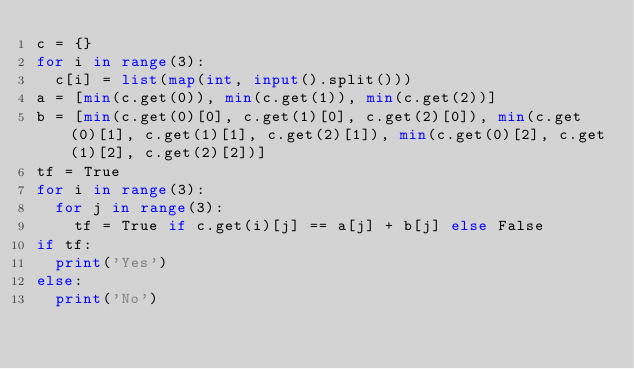<code> <loc_0><loc_0><loc_500><loc_500><_Python_>c = {}
for i in range(3):
  c[i] = list(map(int, input().split()))
a = [min(c.get(0)), min(c.get(1)), min(c.get(2))]
b = [min(c.get(0)[0], c.get(1)[0], c.get(2)[0]), min(c.get(0)[1], c.get(1)[1], c.get(2)[1]), min(c.get(0)[2], c.get(1)[2], c.get(2)[2])]
tf = True
for i in range(3):
  for j in range(3):
    tf = True if c.get(i)[j] == a[j] + b[j] else False
if tf:
  print('Yes')
else:
  print('No')</code> 